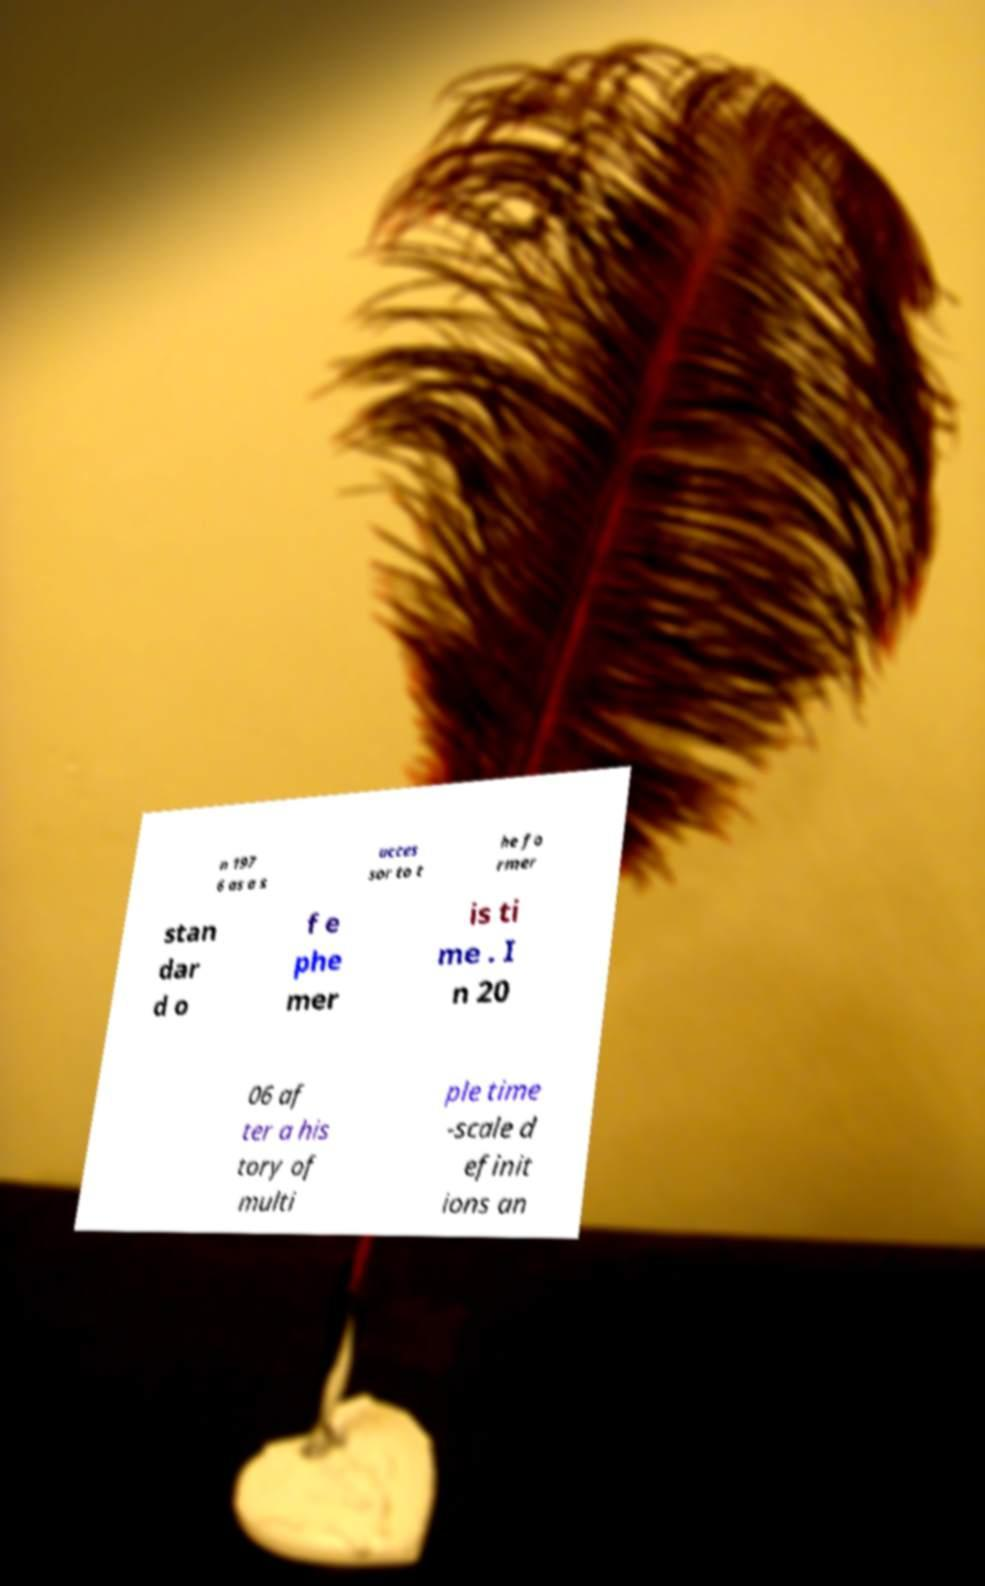Please identify and transcribe the text found in this image. n 197 6 as a s ucces sor to t he fo rmer stan dar d o f e phe mer is ti me . I n 20 06 af ter a his tory of multi ple time -scale d efinit ions an 